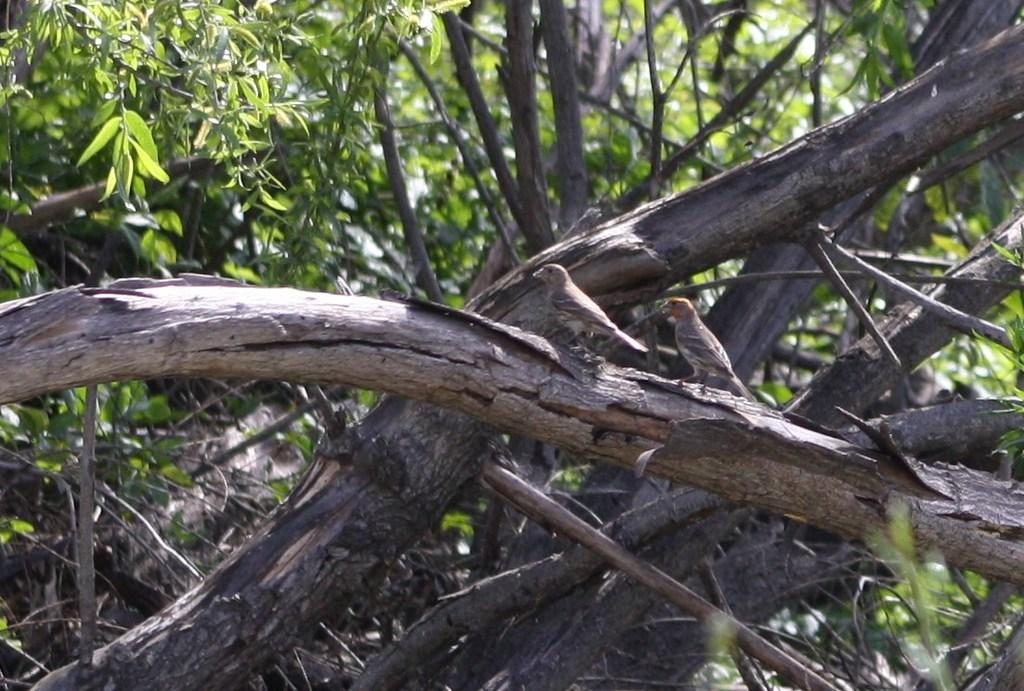What animals can be seen in the image? There are birds on a tree in the image. What type of vegetation is visible in the image? There are trees in the image. Can you describe the background of the image? The background of the image includes trees. Where is the throne located in the image? There is no throne present in the image. What type of veil can be seen on the birds in the image? There are no veils on the birds in the image; they are simply perched on the tree. 